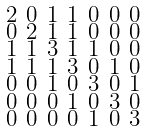<formula> <loc_0><loc_0><loc_500><loc_500>\begin{smallmatrix} 2 & 0 & 1 & 1 & 0 & 0 & 0 \\ 0 & 2 & 1 & 1 & 0 & 0 & 0 \\ 1 & 1 & 3 & 1 & 1 & 0 & 0 \\ 1 & 1 & 1 & 3 & 0 & 1 & 0 \\ 0 & 0 & 1 & 0 & 3 & 0 & 1 \\ 0 & 0 & 0 & 1 & 0 & 3 & 0 \\ 0 & 0 & 0 & 0 & 1 & 0 & 3 \end{smallmatrix}</formula> 